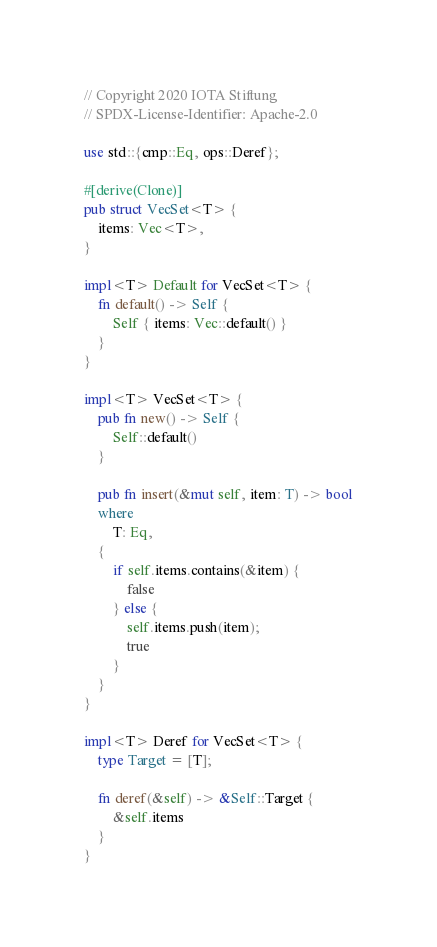<code> <loc_0><loc_0><loc_500><loc_500><_Rust_>// Copyright 2020 IOTA Stiftung
// SPDX-License-Identifier: Apache-2.0

use std::{cmp::Eq, ops::Deref};

#[derive(Clone)]
pub struct VecSet<T> {
    items: Vec<T>,
}

impl<T> Default for VecSet<T> {
    fn default() -> Self {
        Self { items: Vec::default() }
    }
}

impl<T> VecSet<T> {
    pub fn new() -> Self {
        Self::default()
    }

    pub fn insert(&mut self, item: T) -> bool
    where
        T: Eq,
    {
        if self.items.contains(&item) {
            false
        } else {
            self.items.push(item);
            true
        }
    }
}

impl<T> Deref for VecSet<T> {
    type Target = [T];

    fn deref(&self) -> &Self::Target {
        &self.items
    }
}
</code> 